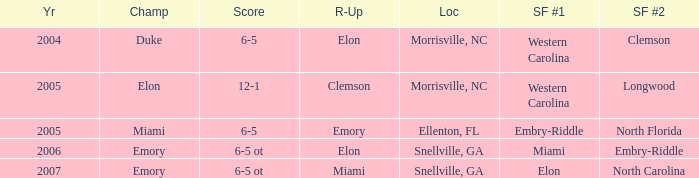When Embry-Riddle made it to the first semi finalist slot, list all the runners up. Emory. 